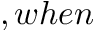Convert formula to latex. <formula><loc_0><loc_0><loc_500><loc_500>, w h e n</formula> 